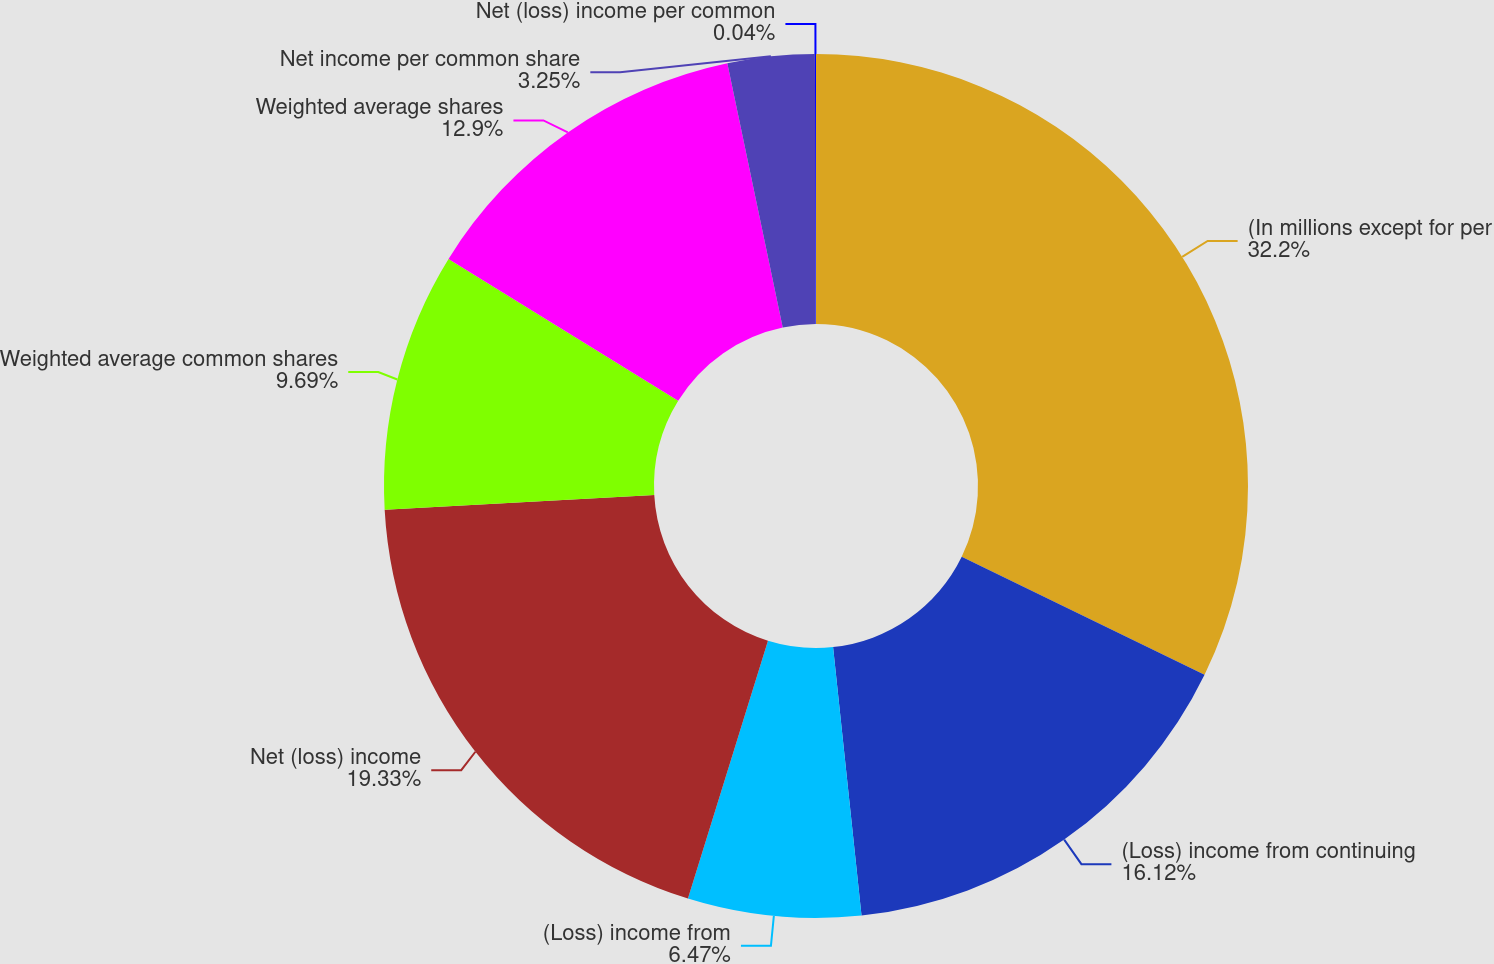Convert chart to OTSL. <chart><loc_0><loc_0><loc_500><loc_500><pie_chart><fcel>(In millions except for per<fcel>(Loss) income from continuing<fcel>(Loss) income from<fcel>Net (loss) income<fcel>Weighted average common shares<fcel>Weighted average shares<fcel>Net income per common share<fcel>Net (loss) income per common<nl><fcel>32.2%<fcel>16.12%<fcel>6.47%<fcel>19.33%<fcel>9.69%<fcel>12.9%<fcel>3.25%<fcel>0.04%<nl></chart> 